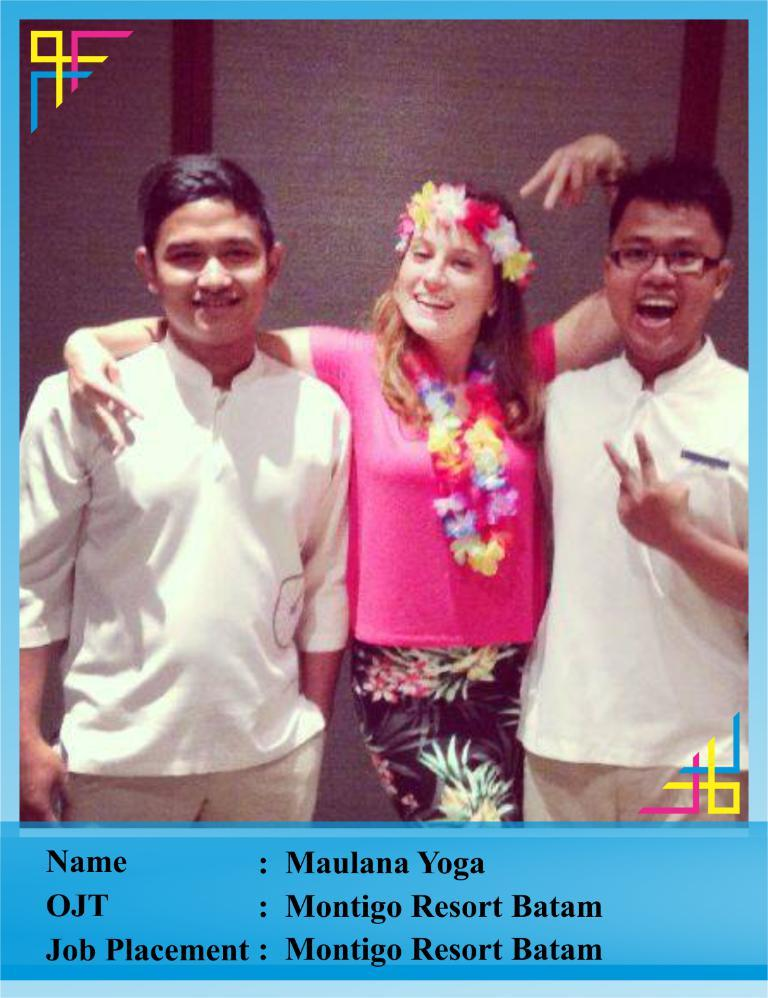How many people are present in the image? There are three persons standing in the image. What can be seen in addition to the people in the image? There is a text visible in the image. What type of background is present in the image? There is a wall in the image. What type of test is being conducted in the image? There is no test being conducted in the image; it only shows three persons standing and a text visible on a wall. 